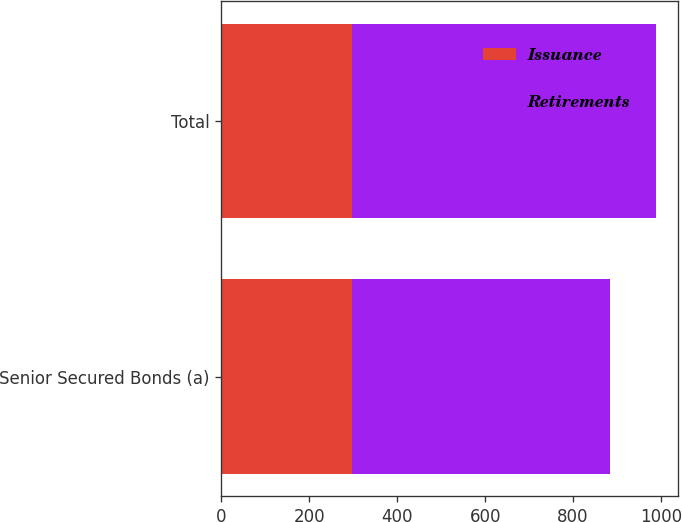<chart> <loc_0><loc_0><loc_500><loc_500><stacked_bar_chart><ecel><fcel>Senior Secured Bonds (a)<fcel>Total<nl><fcel>Issuance<fcel>298<fcel>298<nl><fcel>Retirements<fcel>586<fcel>690<nl></chart> 